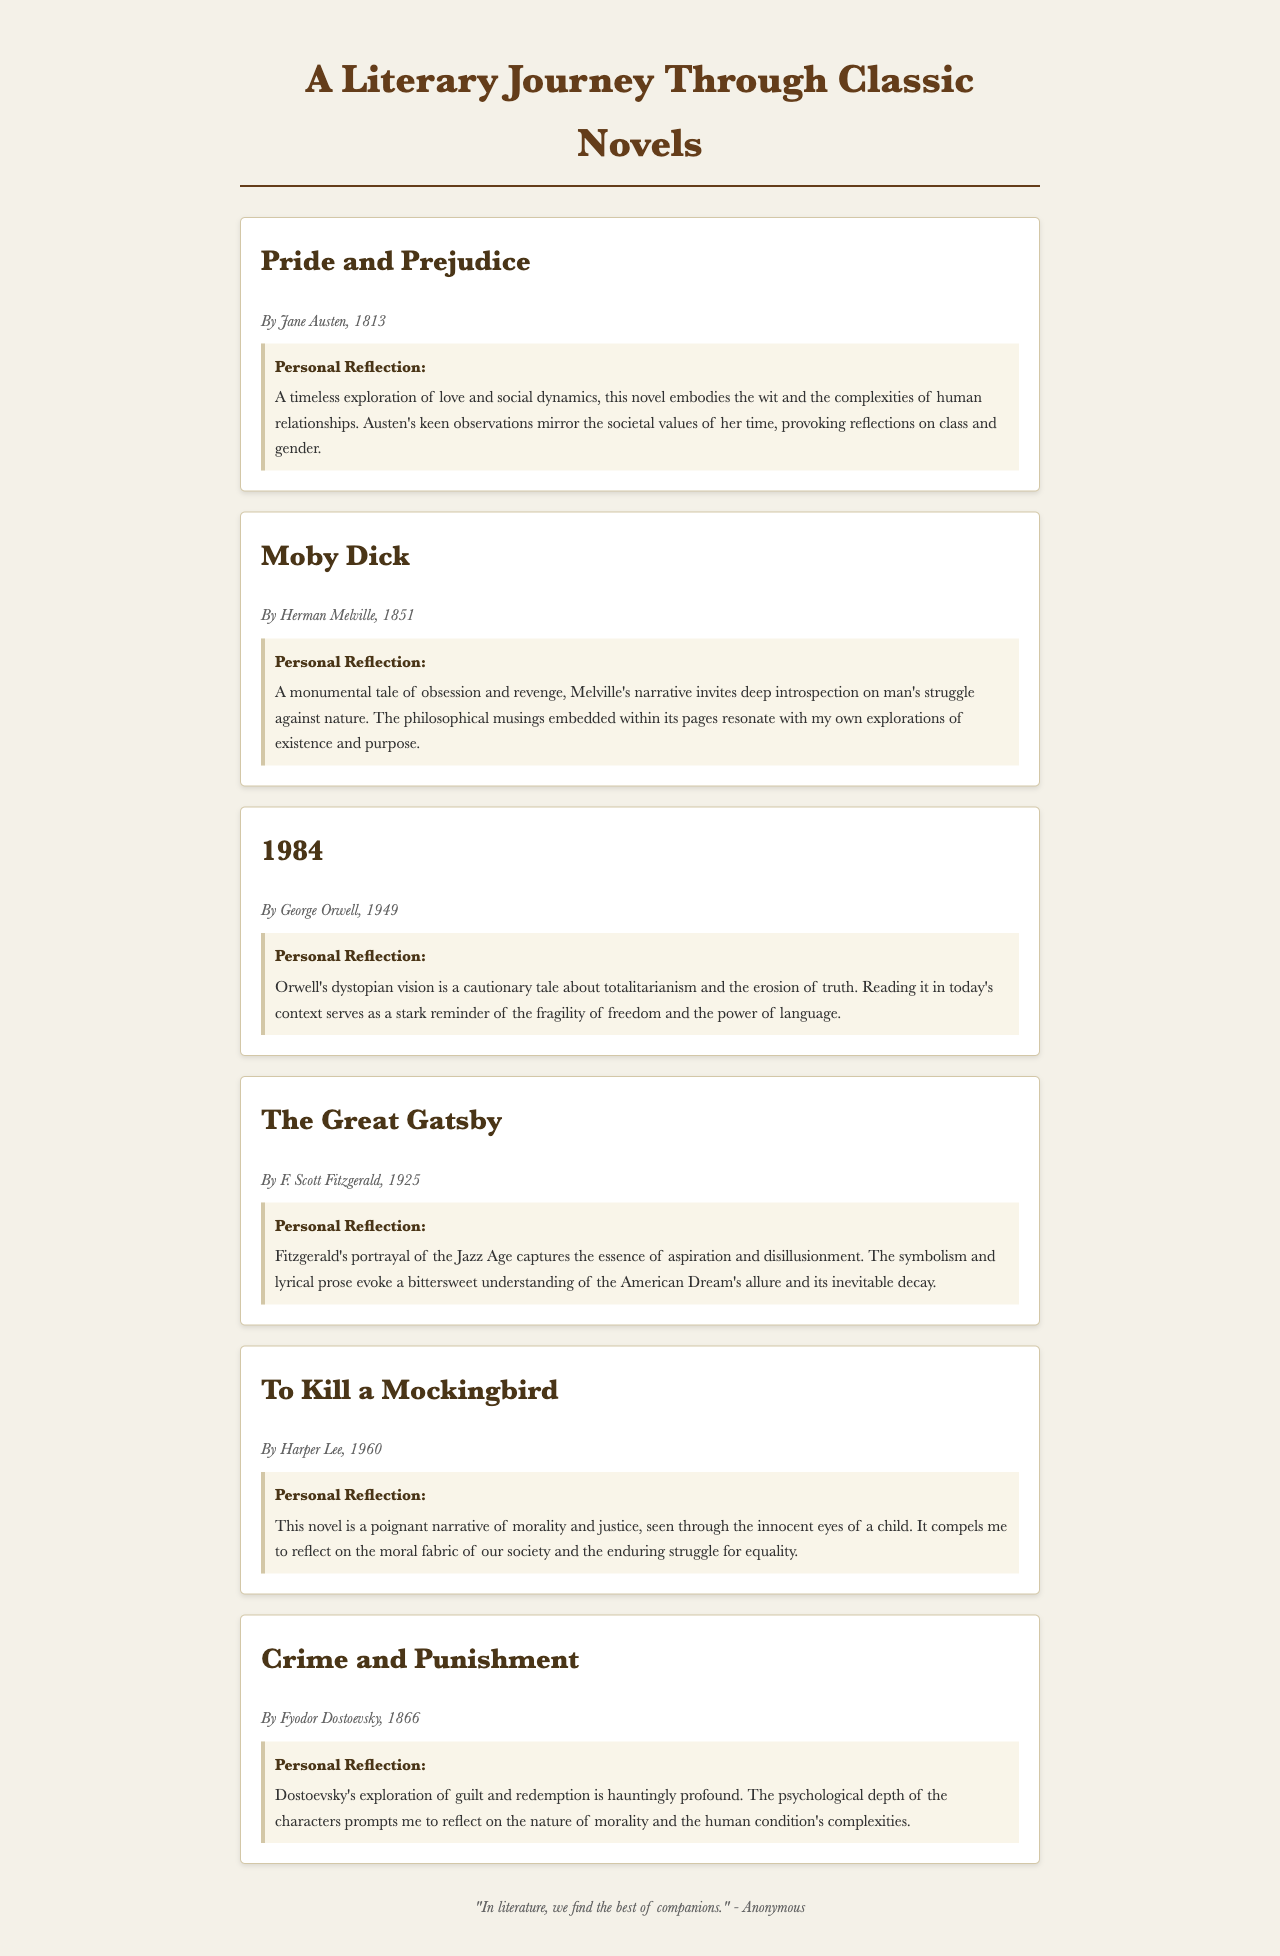What is the title of the first novel listed? The title of the first novel listed in the document is "Pride and Prejudice."
Answer: Pride and Prejudice Who is the author of "Moby Dick"? The author of "Moby Dick," as stated in the document, is Herman Melville.
Answer: Herman Melville In what year was "1984" published? "1984" was published in the year 1949, according to the document.
Answer: 1949 Which novel discusses morality and justice? The novel that discusses morality and justice, as noted, is "To Kill a Mockingbird."
Answer: To Kill a Mockingbird What is the personal reflection on "The Great Gatsby"? The personal reflection on "The Great Gatsby" relates to aspiration and disillusionment.
Answer: Aspiration and disillusionment How many classic novels are mentioned in the document? The document mentions a total of six classic novels.
Answer: Six What theme is highlighted in "Crime and Punishment"? The theme highlighted in "Crime and Punishment" is guilt and redemption.
Answer: Guilt and redemption Which book is described as a "cautionary tale about totalitarianism"? The book described as a "cautionary tale about totalitarianism" is "1984."
Answer: 1984 What literary period does "The Great Gatsby" represent? "The Great Gatsby" represents the Jazz Age, as stated in the personal reflection.
Answer: Jazz Age 